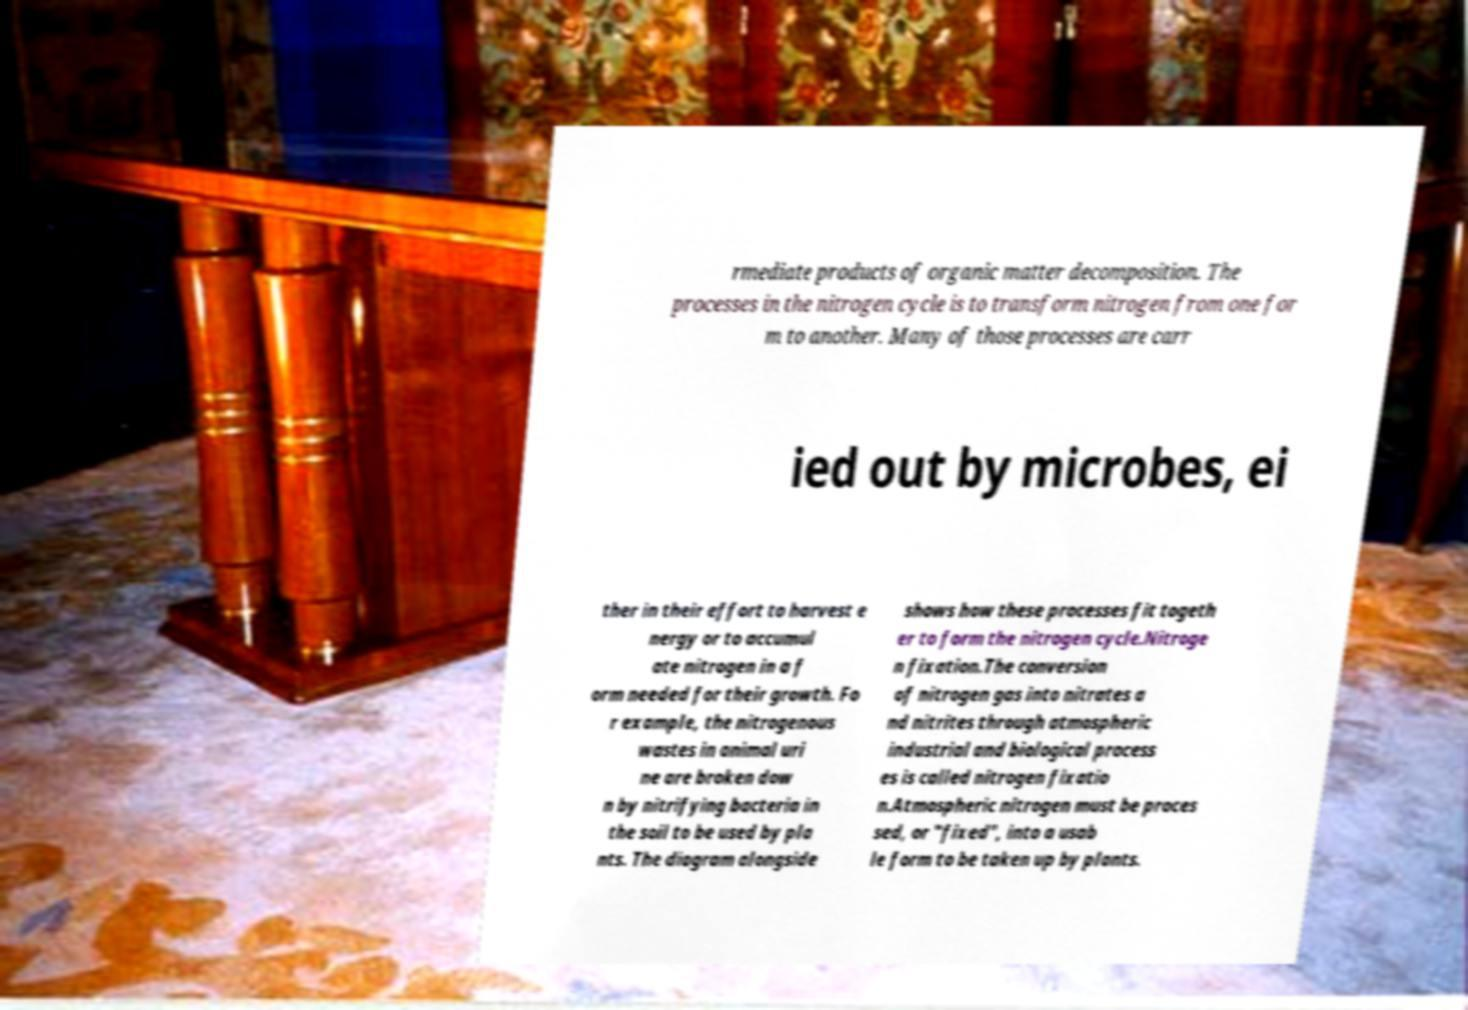Can you read and provide the text displayed in the image?This photo seems to have some interesting text. Can you extract and type it out for me? rmediate products of organic matter decomposition. The processes in the nitrogen cycle is to transform nitrogen from one for m to another. Many of those processes are carr ied out by microbes, ei ther in their effort to harvest e nergy or to accumul ate nitrogen in a f orm needed for their growth. Fo r example, the nitrogenous wastes in animal uri ne are broken dow n by nitrifying bacteria in the soil to be used by pla nts. The diagram alongside shows how these processes fit togeth er to form the nitrogen cycle.Nitroge n fixation.The conversion of nitrogen gas into nitrates a nd nitrites through atmospheric industrial and biological process es is called nitrogen fixatio n.Atmospheric nitrogen must be proces sed, or "fixed", into a usab le form to be taken up by plants. 